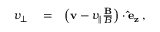Convert formula to latex. <formula><loc_0><loc_0><loc_500><loc_500>\begin{array} { r l r } { v _ { \perp } } & = } & { \left ( v - v _ { \| } \frac { B } { B } \right ) \cdot \hat { e } _ { z } \, , } \end{array}</formula> 